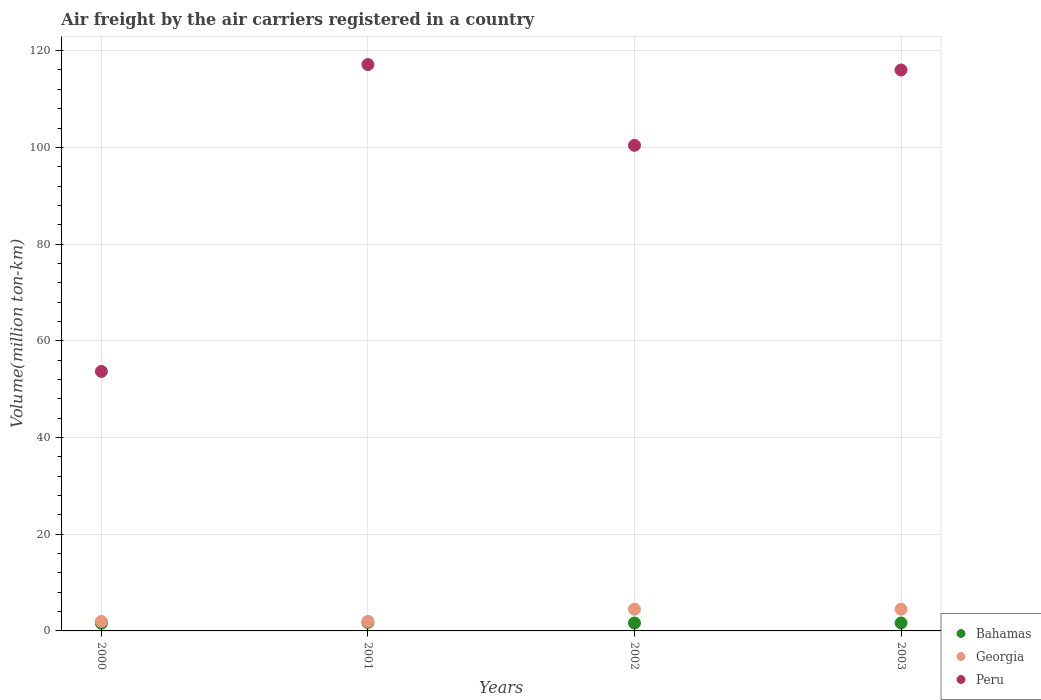How many different coloured dotlines are there?
Offer a terse response. 3. What is the volume of the air carriers in Peru in 2000?
Provide a succinct answer. 53.66. Across all years, what is the maximum volume of the air carriers in Georgia?
Your response must be concise. 4.49. Across all years, what is the minimum volume of the air carriers in Bahamas?
Make the answer very short. 1.6. What is the total volume of the air carriers in Georgia in the graph?
Offer a very short reply. 12.92. What is the difference between the volume of the air carriers in Peru in 2002 and that in 2003?
Provide a succinct answer. -15.58. What is the difference between the volume of the air carriers in Peru in 2002 and the volume of the air carriers in Georgia in 2001?
Your answer should be compact. 98.44. What is the average volume of the air carriers in Peru per year?
Ensure brevity in your answer.  96.8. In the year 2001, what is the difference between the volume of the air carriers in Bahamas and volume of the air carriers in Peru?
Provide a succinct answer. -115.37. What is the ratio of the volume of the air carriers in Peru in 2001 to that in 2003?
Your answer should be very brief. 1.01. What is the difference between the highest and the second highest volume of the air carriers in Georgia?
Offer a very short reply. 0.01. What is the difference between the highest and the lowest volume of the air carriers in Georgia?
Your answer should be very brief. 2.52. In how many years, is the volume of the air carriers in Bahamas greater than the average volume of the air carriers in Bahamas taken over all years?
Give a very brief answer. 1. Is the sum of the volume of the air carriers in Peru in 2001 and 2003 greater than the maximum volume of the air carriers in Georgia across all years?
Provide a succinct answer. Yes. Is it the case that in every year, the sum of the volume of the air carriers in Georgia and volume of the air carriers in Bahamas  is greater than the volume of the air carriers in Peru?
Offer a terse response. No. Is the volume of the air carriers in Bahamas strictly greater than the volume of the air carriers in Georgia over the years?
Ensure brevity in your answer.  No. How many dotlines are there?
Offer a very short reply. 3. How many years are there in the graph?
Keep it short and to the point. 4. Are the values on the major ticks of Y-axis written in scientific E-notation?
Your response must be concise. No. Does the graph contain any zero values?
Provide a short and direct response. No. Where does the legend appear in the graph?
Keep it short and to the point. Bottom right. What is the title of the graph?
Offer a terse response. Air freight by the air carriers registered in a country. What is the label or title of the X-axis?
Give a very brief answer. Years. What is the label or title of the Y-axis?
Your answer should be compact. Volume(million ton-km). What is the Volume(million ton-km) in Bahamas in 2000?
Keep it short and to the point. 1.6. What is the Volume(million ton-km) of Georgia in 2000?
Give a very brief answer. 1.97. What is the Volume(million ton-km) in Peru in 2000?
Offer a very short reply. 53.66. What is the Volume(million ton-km) in Bahamas in 2001?
Your answer should be very brief. 1.76. What is the Volume(million ton-km) in Georgia in 2001?
Your response must be concise. 1.97. What is the Volume(million ton-km) in Peru in 2001?
Your response must be concise. 117.13. What is the Volume(million ton-km) of Bahamas in 2002?
Your answer should be compact. 1.64. What is the Volume(million ton-km) of Georgia in 2002?
Ensure brevity in your answer.  4.48. What is the Volume(million ton-km) in Peru in 2002?
Ensure brevity in your answer.  100.42. What is the Volume(million ton-km) of Bahamas in 2003?
Ensure brevity in your answer.  1.64. What is the Volume(million ton-km) in Georgia in 2003?
Offer a terse response. 4.49. What is the Volume(million ton-km) in Peru in 2003?
Provide a succinct answer. 116. Across all years, what is the maximum Volume(million ton-km) in Bahamas?
Give a very brief answer. 1.76. Across all years, what is the maximum Volume(million ton-km) in Georgia?
Provide a succinct answer. 4.49. Across all years, what is the maximum Volume(million ton-km) in Peru?
Give a very brief answer. 117.13. Across all years, what is the minimum Volume(million ton-km) of Bahamas?
Your answer should be compact. 1.6. Across all years, what is the minimum Volume(million ton-km) of Georgia?
Keep it short and to the point. 1.97. Across all years, what is the minimum Volume(million ton-km) in Peru?
Keep it short and to the point. 53.66. What is the total Volume(million ton-km) in Bahamas in the graph?
Ensure brevity in your answer.  6.64. What is the total Volume(million ton-km) of Georgia in the graph?
Provide a short and direct response. 12.92. What is the total Volume(million ton-km) of Peru in the graph?
Your answer should be compact. 387.21. What is the difference between the Volume(million ton-km) of Bahamas in 2000 and that in 2001?
Your answer should be very brief. -0.17. What is the difference between the Volume(million ton-km) in Georgia in 2000 and that in 2001?
Provide a short and direct response. 0. What is the difference between the Volume(million ton-km) of Peru in 2000 and that in 2001?
Your response must be concise. -63.47. What is the difference between the Volume(million ton-km) in Bahamas in 2000 and that in 2002?
Your answer should be very brief. -0.04. What is the difference between the Volume(million ton-km) of Georgia in 2000 and that in 2002?
Offer a terse response. -2.51. What is the difference between the Volume(million ton-km) in Peru in 2000 and that in 2002?
Provide a succinct answer. -46.76. What is the difference between the Volume(million ton-km) in Bahamas in 2000 and that in 2003?
Keep it short and to the point. -0.05. What is the difference between the Volume(million ton-km) of Georgia in 2000 and that in 2003?
Give a very brief answer. -2.52. What is the difference between the Volume(million ton-km) in Peru in 2000 and that in 2003?
Your answer should be compact. -62.34. What is the difference between the Volume(million ton-km) in Bahamas in 2001 and that in 2002?
Give a very brief answer. 0.13. What is the difference between the Volume(million ton-km) of Georgia in 2001 and that in 2002?
Provide a short and direct response. -2.51. What is the difference between the Volume(million ton-km) of Peru in 2001 and that in 2002?
Your answer should be very brief. 16.71. What is the difference between the Volume(million ton-km) of Bahamas in 2001 and that in 2003?
Your answer should be compact. 0.12. What is the difference between the Volume(million ton-km) in Georgia in 2001 and that in 2003?
Keep it short and to the point. -2.52. What is the difference between the Volume(million ton-km) in Peru in 2001 and that in 2003?
Ensure brevity in your answer.  1.13. What is the difference between the Volume(million ton-km) in Bahamas in 2002 and that in 2003?
Offer a terse response. -0.01. What is the difference between the Volume(million ton-km) of Georgia in 2002 and that in 2003?
Your answer should be very brief. -0.01. What is the difference between the Volume(million ton-km) in Peru in 2002 and that in 2003?
Provide a succinct answer. -15.58. What is the difference between the Volume(million ton-km) of Bahamas in 2000 and the Volume(million ton-km) of Georgia in 2001?
Provide a short and direct response. -0.38. What is the difference between the Volume(million ton-km) in Bahamas in 2000 and the Volume(million ton-km) in Peru in 2001?
Your answer should be very brief. -115.53. What is the difference between the Volume(million ton-km) of Georgia in 2000 and the Volume(million ton-km) of Peru in 2001?
Make the answer very short. -115.16. What is the difference between the Volume(million ton-km) in Bahamas in 2000 and the Volume(million ton-km) in Georgia in 2002?
Offer a terse response. -2.89. What is the difference between the Volume(million ton-km) in Bahamas in 2000 and the Volume(million ton-km) in Peru in 2002?
Make the answer very short. -98.82. What is the difference between the Volume(million ton-km) of Georgia in 2000 and the Volume(million ton-km) of Peru in 2002?
Your answer should be compact. -98.44. What is the difference between the Volume(million ton-km) in Bahamas in 2000 and the Volume(million ton-km) in Georgia in 2003?
Offer a terse response. -2.89. What is the difference between the Volume(million ton-km) in Bahamas in 2000 and the Volume(million ton-km) in Peru in 2003?
Keep it short and to the point. -114.4. What is the difference between the Volume(million ton-km) in Georgia in 2000 and the Volume(million ton-km) in Peru in 2003?
Give a very brief answer. -114.03. What is the difference between the Volume(million ton-km) in Bahamas in 2001 and the Volume(million ton-km) in Georgia in 2002?
Provide a short and direct response. -2.72. What is the difference between the Volume(million ton-km) of Bahamas in 2001 and the Volume(million ton-km) of Peru in 2002?
Provide a short and direct response. -98.65. What is the difference between the Volume(million ton-km) in Georgia in 2001 and the Volume(million ton-km) in Peru in 2002?
Ensure brevity in your answer.  -98.44. What is the difference between the Volume(million ton-km) of Bahamas in 2001 and the Volume(million ton-km) of Georgia in 2003?
Your answer should be compact. -2.73. What is the difference between the Volume(million ton-km) of Bahamas in 2001 and the Volume(million ton-km) of Peru in 2003?
Ensure brevity in your answer.  -114.24. What is the difference between the Volume(million ton-km) in Georgia in 2001 and the Volume(million ton-km) in Peru in 2003?
Provide a short and direct response. -114.03. What is the difference between the Volume(million ton-km) of Bahamas in 2002 and the Volume(million ton-km) of Georgia in 2003?
Offer a terse response. -2.85. What is the difference between the Volume(million ton-km) of Bahamas in 2002 and the Volume(million ton-km) of Peru in 2003?
Your answer should be very brief. -114.36. What is the difference between the Volume(million ton-km) of Georgia in 2002 and the Volume(million ton-km) of Peru in 2003?
Offer a very short reply. -111.52. What is the average Volume(million ton-km) in Bahamas per year?
Give a very brief answer. 1.66. What is the average Volume(million ton-km) of Georgia per year?
Make the answer very short. 3.23. What is the average Volume(million ton-km) in Peru per year?
Keep it short and to the point. 96.8. In the year 2000, what is the difference between the Volume(million ton-km) of Bahamas and Volume(million ton-km) of Georgia?
Provide a succinct answer. -0.38. In the year 2000, what is the difference between the Volume(million ton-km) of Bahamas and Volume(million ton-km) of Peru?
Your answer should be compact. -52.06. In the year 2000, what is the difference between the Volume(million ton-km) in Georgia and Volume(million ton-km) in Peru?
Make the answer very short. -51.69. In the year 2001, what is the difference between the Volume(million ton-km) in Bahamas and Volume(million ton-km) in Georgia?
Your answer should be very brief. -0.21. In the year 2001, what is the difference between the Volume(million ton-km) in Bahamas and Volume(million ton-km) in Peru?
Offer a very short reply. -115.37. In the year 2001, what is the difference between the Volume(million ton-km) of Georgia and Volume(million ton-km) of Peru?
Keep it short and to the point. -115.16. In the year 2002, what is the difference between the Volume(million ton-km) in Bahamas and Volume(million ton-km) in Georgia?
Offer a very short reply. -2.85. In the year 2002, what is the difference between the Volume(million ton-km) in Bahamas and Volume(million ton-km) in Peru?
Make the answer very short. -98.78. In the year 2002, what is the difference between the Volume(million ton-km) of Georgia and Volume(million ton-km) of Peru?
Provide a short and direct response. -95.93. In the year 2003, what is the difference between the Volume(million ton-km) in Bahamas and Volume(million ton-km) in Georgia?
Give a very brief answer. -2.85. In the year 2003, what is the difference between the Volume(million ton-km) in Bahamas and Volume(million ton-km) in Peru?
Your response must be concise. -114.36. In the year 2003, what is the difference between the Volume(million ton-km) in Georgia and Volume(million ton-km) in Peru?
Provide a short and direct response. -111.51. What is the ratio of the Volume(million ton-km) in Bahamas in 2000 to that in 2001?
Offer a very short reply. 0.91. What is the ratio of the Volume(million ton-km) of Peru in 2000 to that in 2001?
Provide a short and direct response. 0.46. What is the ratio of the Volume(million ton-km) in Bahamas in 2000 to that in 2002?
Your answer should be very brief. 0.98. What is the ratio of the Volume(million ton-km) in Georgia in 2000 to that in 2002?
Keep it short and to the point. 0.44. What is the ratio of the Volume(million ton-km) of Peru in 2000 to that in 2002?
Offer a terse response. 0.53. What is the ratio of the Volume(million ton-km) of Bahamas in 2000 to that in 2003?
Make the answer very short. 0.97. What is the ratio of the Volume(million ton-km) in Georgia in 2000 to that in 2003?
Ensure brevity in your answer.  0.44. What is the ratio of the Volume(million ton-km) in Peru in 2000 to that in 2003?
Provide a short and direct response. 0.46. What is the ratio of the Volume(million ton-km) of Bahamas in 2001 to that in 2002?
Keep it short and to the point. 1.08. What is the ratio of the Volume(million ton-km) of Georgia in 2001 to that in 2002?
Give a very brief answer. 0.44. What is the ratio of the Volume(million ton-km) of Peru in 2001 to that in 2002?
Your answer should be very brief. 1.17. What is the ratio of the Volume(million ton-km) in Bahamas in 2001 to that in 2003?
Ensure brevity in your answer.  1.07. What is the ratio of the Volume(million ton-km) of Georgia in 2001 to that in 2003?
Offer a very short reply. 0.44. What is the ratio of the Volume(million ton-km) of Peru in 2001 to that in 2003?
Provide a short and direct response. 1.01. What is the ratio of the Volume(million ton-km) of Peru in 2002 to that in 2003?
Provide a short and direct response. 0.87. What is the difference between the highest and the second highest Volume(million ton-km) of Bahamas?
Offer a terse response. 0.12. What is the difference between the highest and the second highest Volume(million ton-km) in Georgia?
Provide a short and direct response. 0.01. What is the difference between the highest and the second highest Volume(million ton-km) of Peru?
Ensure brevity in your answer.  1.13. What is the difference between the highest and the lowest Volume(million ton-km) of Bahamas?
Offer a terse response. 0.17. What is the difference between the highest and the lowest Volume(million ton-km) in Georgia?
Offer a very short reply. 2.52. What is the difference between the highest and the lowest Volume(million ton-km) of Peru?
Ensure brevity in your answer.  63.47. 